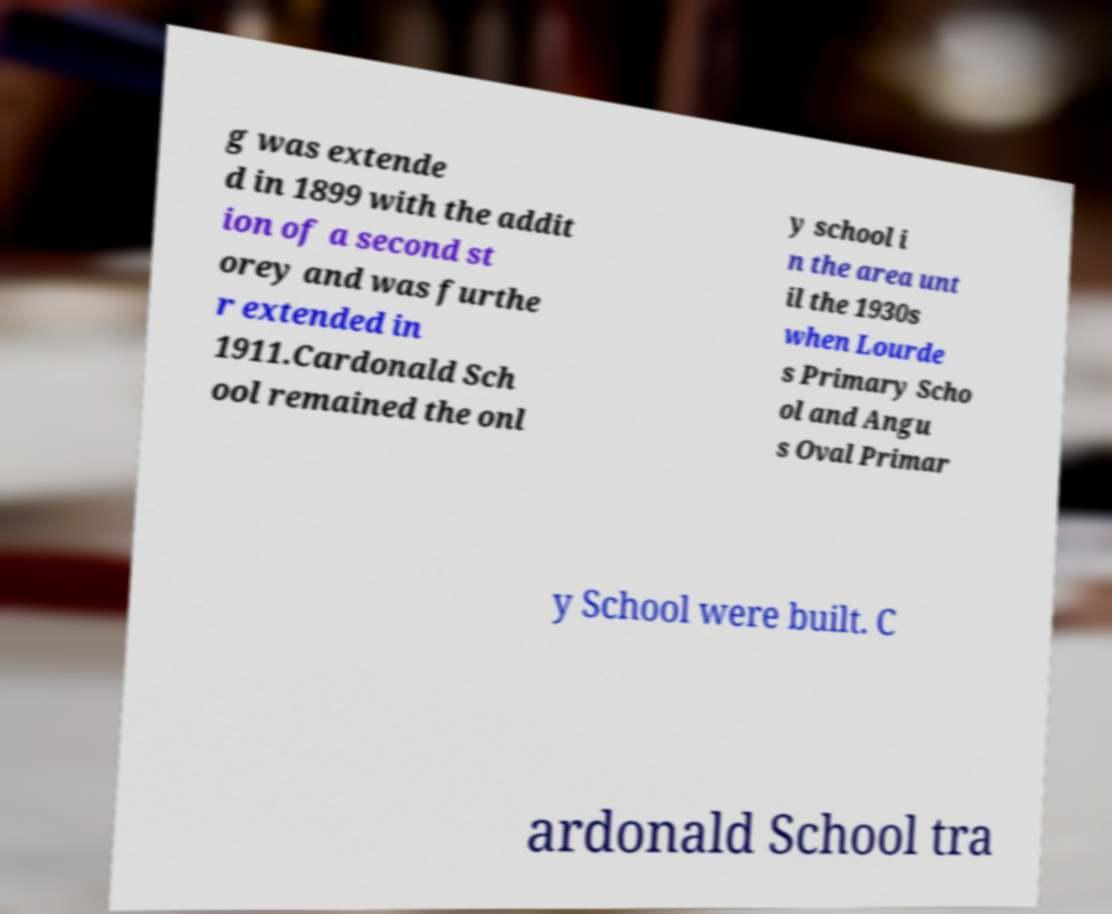What messages or text are displayed in this image? I need them in a readable, typed format. g was extende d in 1899 with the addit ion of a second st orey and was furthe r extended in 1911.Cardonald Sch ool remained the onl y school i n the area unt il the 1930s when Lourde s Primary Scho ol and Angu s Oval Primar y School were built. C ardonald School tra 